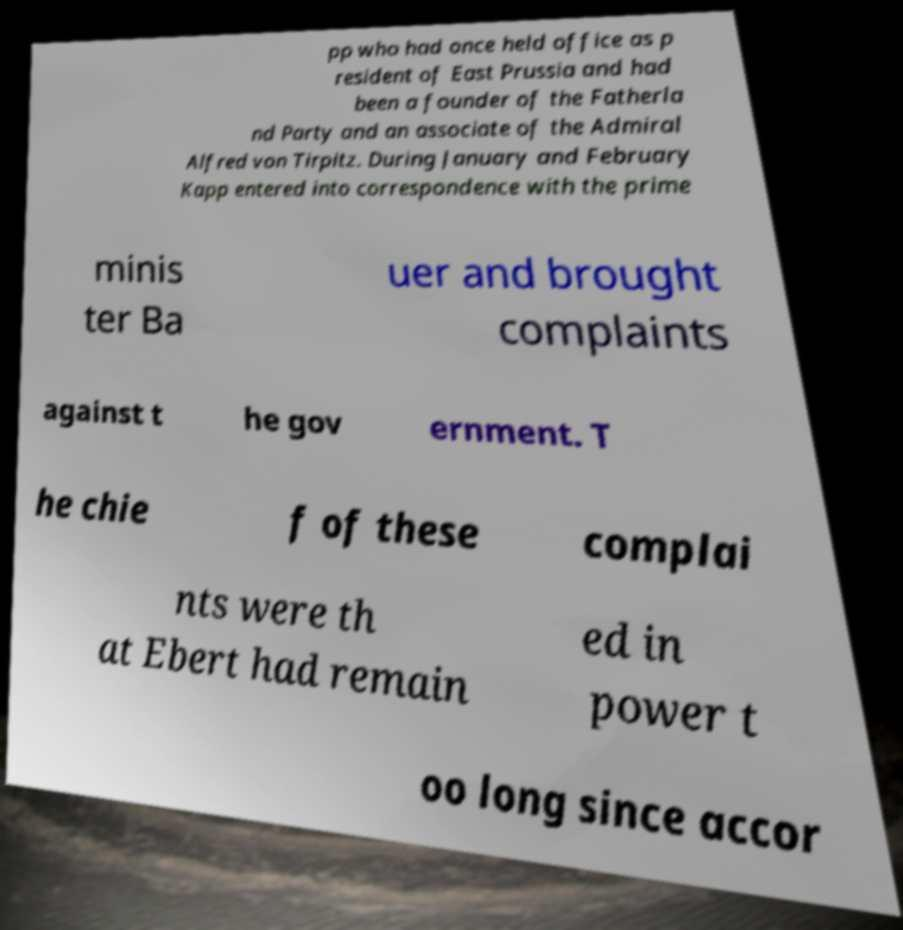There's text embedded in this image that I need extracted. Can you transcribe it verbatim? pp who had once held office as p resident of East Prussia and had been a founder of the Fatherla nd Party and an associate of the Admiral Alfred von Tirpitz. During January and February Kapp entered into correspondence with the prime minis ter Ba uer and brought complaints against t he gov ernment. T he chie f of these complai nts were th at Ebert had remain ed in power t oo long since accor 